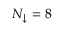Convert formula to latex. <formula><loc_0><loc_0><loc_500><loc_500>N _ { \downarrow } = 8</formula> 